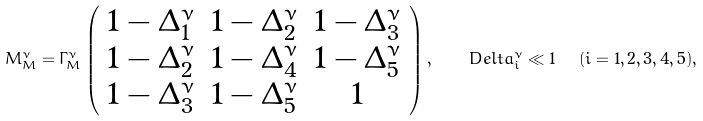<formula> <loc_0><loc_0><loc_500><loc_500>M ^ { \nu } _ { M } = \Gamma ^ { \nu } _ { M } \left ( \begin{array} { c c c } 1 - \Delta ^ { \nu } _ { 1 } & 1 - \Delta ^ { \nu } _ { 2 } & 1 - \Delta ^ { \nu } _ { 3 } \\ 1 - \Delta ^ { \nu } _ { 2 } & 1 - \Delta ^ { \nu } _ { 4 } & 1 - \Delta ^ { \nu } _ { 5 } \\ 1 - \Delta ^ { \nu } _ { 3 } & 1 - \Delta ^ { \nu } _ { 5 } & 1 \end{array} \right ) , \ \ \ D e l t a ^ { \nu } _ { i } \ll 1 \ \ ( i = 1 , 2 , 3 , 4 , 5 ) , \quad</formula> 